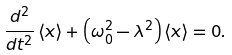Convert formula to latex. <formula><loc_0><loc_0><loc_500><loc_500>\frac { d ^ { 2 } } { d t ^ { 2 } } \left \langle x \right \rangle + \left ( \omega _ { 0 } ^ { 2 } - \lambda ^ { 2 } \right ) \left \langle x \right \rangle = 0 .</formula> 